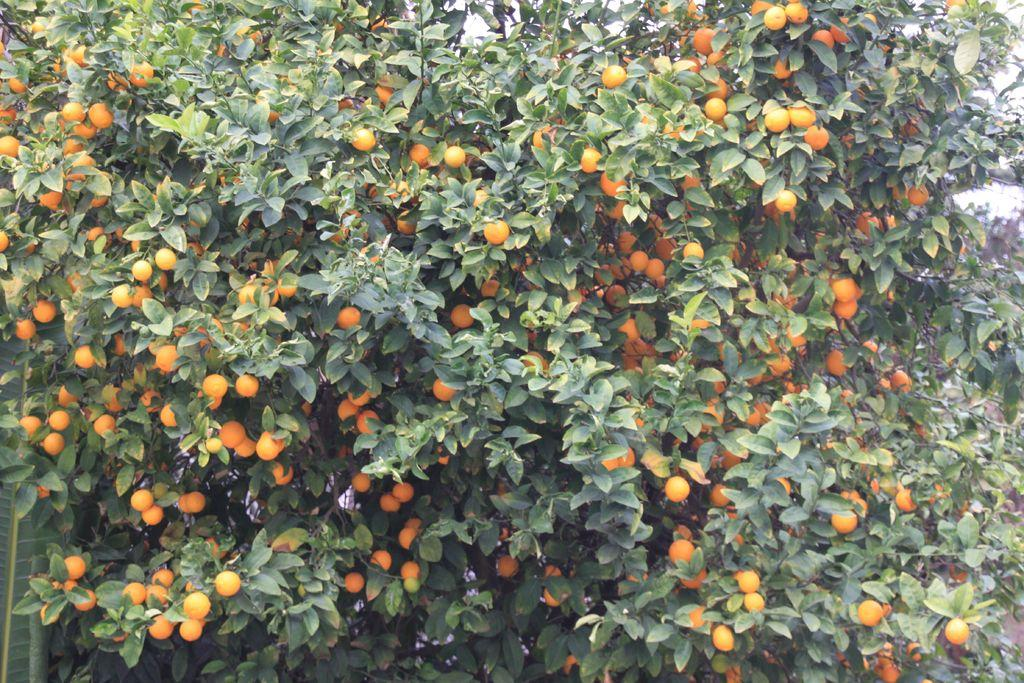What is present in the picture? There is a tree in the picture. What can be found on the tree? There are oranges on the tree. What shape is the butter on the tree? There is no butter present in the image; it only features a tree with oranges. 